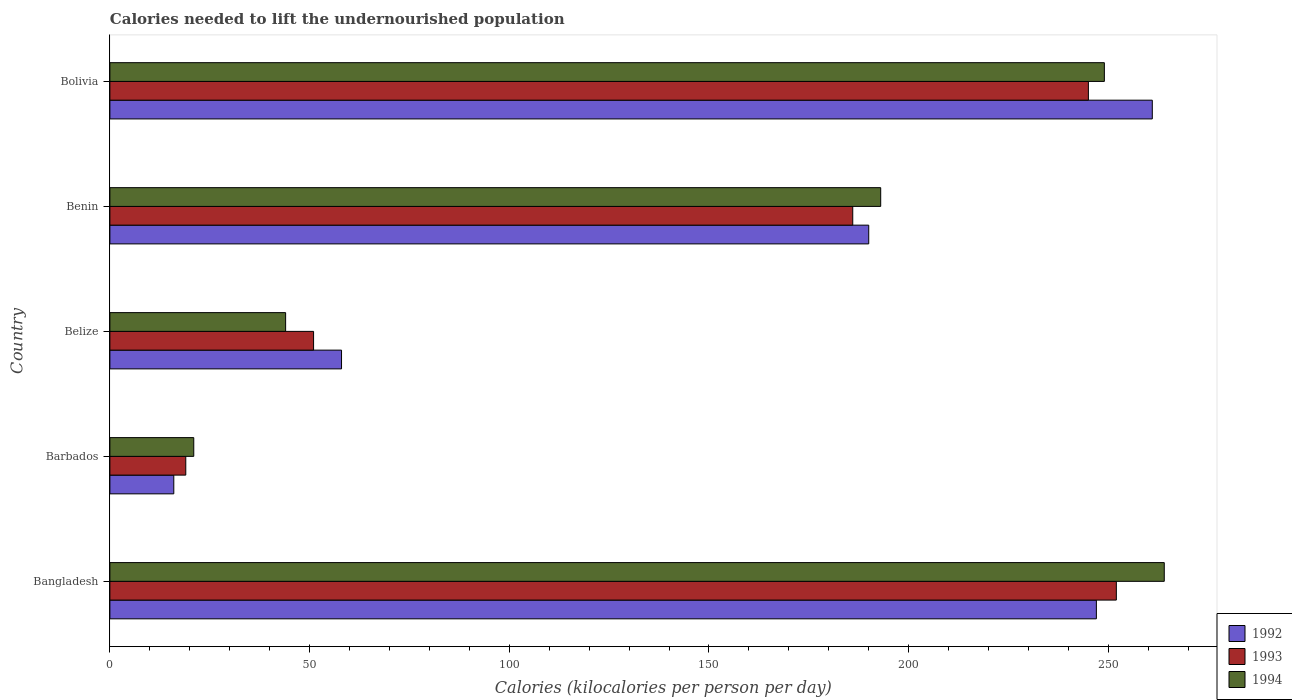Are the number of bars per tick equal to the number of legend labels?
Ensure brevity in your answer.  Yes. Are the number of bars on each tick of the Y-axis equal?
Your answer should be compact. Yes. How many bars are there on the 5th tick from the top?
Your answer should be compact. 3. What is the label of the 2nd group of bars from the top?
Ensure brevity in your answer.  Benin. In how many cases, is the number of bars for a given country not equal to the number of legend labels?
Ensure brevity in your answer.  0. What is the total calories needed to lift the undernourished population in 1992 in Bangladesh?
Your answer should be very brief. 247. Across all countries, what is the maximum total calories needed to lift the undernourished population in 1993?
Your answer should be very brief. 252. In which country was the total calories needed to lift the undernourished population in 1994 maximum?
Offer a terse response. Bangladesh. In which country was the total calories needed to lift the undernourished population in 1992 minimum?
Your answer should be very brief. Barbados. What is the total total calories needed to lift the undernourished population in 1993 in the graph?
Ensure brevity in your answer.  753. What is the difference between the total calories needed to lift the undernourished population in 1993 in Belize and that in Benin?
Provide a succinct answer. -135. What is the difference between the total calories needed to lift the undernourished population in 1994 in Bangladesh and the total calories needed to lift the undernourished population in 1992 in Barbados?
Ensure brevity in your answer.  248. What is the average total calories needed to lift the undernourished population in 1994 per country?
Provide a short and direct response. 154.2. What is the ratio of the total calories needed to lift the undernourished population in 1992 in Benin to that in Bolivia?
Your answer should be very brief. 0.73. Is the difference between the total calories needed to lift the undernourished population in 1993 in Bangladesh and Barbados greater than the difference between the total calories needed to lift the undernourished population in 1992 in Bangladesh and Barbados?
Keep it short and to the point. Yes. What is the difference between the highest and the lowest total calories needed to lift the undernourished population in 1993?
Your response must be concise. 233. In how many countries, is the total calories needed to lift the undernourished population in 1993 greater than the average total calories needed to lift the undernourished population in 1993 taken over all countries?
Your answer should be very brief. 3. Is the sum of the total calories needed to lift the undernourished population in 1992 in Benin and Bolivia greater than the maximum total calories needed to lift the undernourished population in 1994 across all countries?
Give a very brief answer. Yes. What does the 2nd bar from the top in Barbados represents?
Offer a very short reply. 1993. What does the 1st bar from the bottom in Bangladesh represents?
Provide a succinct answer. 1992. Is it the case that in every country, the sum of the total calories needed to lift the undernourished population in 1992 and total calories needed to lift the undernourished population in 1994 is greater than the total calories needed to lift the undernourished population in 1993?
Your answer should be very brief. Yes. How many bars are there?
Provide a short and direct response. 15. Are all the bars in the graph horizontal?
Your response must be concise. Yes. What is the difference between two consecutive major ticks on the X-axis?
Make the answer very short. 50. Does the graph contain grids?
Offer a terse response. No. Where does the legend appear in the graph?
Ensure brevity in your answer.  Bottom right. How many legend labels are there?
Offer a terse response. 3. What is the title of the graph?
Your answer should be compact. Calories needed to lift the undernourished population. Does "1990" appear as one of the legend labels in the graph?
Your response must be concise. No. What is the label or title of the X-axis?
Offer a very short reply. Calories (kilocalories per person per day). What is the Calories (kilocalories per person per day) in 1992 in Bangladesh?
Your answer should be compact. 247. What is the Calories (kilocalories per person per day) of 1993 in Bangladesh?
Your answer should be very brief. 252. What is the Calories (kilocalories per person per day) of 1994 in Bangladesh?
Keep it short and to the point. 264. What is the Calories (kilocalories per person per day) in 1992 in Barbados?
Offer a terse response. 16. What is the Calories (kilocalories per person per day) in 1994 in Barbados?
Provide a succinct answer. 21. What is the Calories (kilocalories per person per day) of 1992 in Belize?
Give a very brief answer. 58. What is the Calories (kilocalories per person per day) of 1994 in Belize?
Offer a very short reply. 44. What is the Calories (kilocalories per person per day) of 1992 in Benin?
Provide a succinct answer. 190. What is the Calories (kilocalories per person per day) of 1993 in Benin?
Provide a short and direct response. 186. What is the Calories (kilocalories per person per day) in 1994 in Benin?
Your answer should be very brief. 193. What is the Calories (kilocalories per person per day) in 1992 in Bolivia?
Your answer should be very brief. 261. What is the Calories (kilocalories per person per day) in 1993 in Bolivia?
Your answer should be very brief. 245. What is the Calories (kilocalories per person per day) of 1994 in Bolivia?
Your response must be concise. 249. Across all countries, what is the maximum Calories (kilocalories per person per day) of 1992?
Give a very brief answer. 261. Across all countries, what is the maximum Calories (kilocalories per person per day) in 1993?
Your response must be concise. 252. Across all countries, what is the maximum Calories (kilocalories per person per day) in 1994?
Your answer should be compact. 264. Across all countries, what is the minimum Calories (kilocalories per person per day) in 1992?
Your answer should be very brief. 16. Across all countries, what is the minimum Calories (kilocalories per person per day) of 1994?
Keep it short and to the point. 21. What is the total Calories (kilocalories per person per day) of 1992 in the graph?
Provide a succinct answer. 772. What is the total Calories (kilocalories per person per day) of 1993 in the graph?
Provide a succinct answer. 753. What is the total Calories (kilocalories per person per day) of 1994 in the graph?
Offer a very short reply. 771. What is the difference between the Calories (kilocalories per person per day) in 1992 in Bangladesh and that in Barbados?
Provide a succinct answer. 231. What is the difference between the Calories (kilocalories per person per day) in 1993 in Bangladesh and that in Barbados?
Give a very brief answer. 233. What is the difference between the Calories (kilocalories per person per day) of 1994 in Bangladesh and that in Barbados?
Make the answer very short. 243. What is the difference between the Calories (kilocalories per person per day) in 1992 in Bangladesh and that in Belize?
Provide a short and direct response. 189. What is the difference between the Calories (kilocalories per person per day) in 1993 in Bangladesh and that in Belize?
Give a very brief answer. 201. What is the difference between the Calories (kilocalories per person per day) of 1994 in Bangladesh and that in Belize?
Your response must be concise. 220. What is the difference between the Calories (kilocalories per person per day) in 1992 in Bangladesh and that in Bolivia?
Your response must be concise. -14. What is the difference between the Calories (kilocalories per person per day) of 1994 in Bangladesh and that in Bolivia?
Your response must be concise. 15. What is the difference between the Calories (kilocalories per person per day) of 1992 in Barbados and that in Belize?
Your answer should be compact. -42. What is the difference between the Calories (kilocalories per person per day) in 1993 in Barbados and that in Belize?
Give a very brief answer. -32. What is the difference between the Calories (kilocalories per person per day) of 1994 in Barbados and that in Belize?
Keep it short and to the point. -23. What is the difference between the Calories (kilocalories per person per day) of 1992 in Barbados and that in Benin?
Offer a terse response. -174. What is the difference between the Calories (kilocalories per person per day) in 1993 in Barbados and that in Benin?
Your response must be concise. -167. What is the difference between the Calories (kilocalories per person per day) in 1994 in Barbados and that in Benin?
Make the answer very short. -172. What is the difference between the Calories (kilocalories per person per day) in 1992 in Barbados and that in Bolivia?
Give a very brief answer. -245. What is the difference between the Calories (kilocalories per person per day) in 1993 in Barbados and that in Bolivia?
Make the answer very short. -226. What is the difference between the Calories (kilocalories per person per day) of 1994 in Barbados and that in Bolivia?
Provide a short and direct response. -228. What is the difference between the Calories (kilocalories per person per day) in 1992 in Belize and that in Benin?
Offer a terse response. -132. What is the difference between the Calories (kilocalories per person per day) of 1993 in Belize and that in Benin?
Your answer should be very brief. -135. What is the difference between the Calories (kilocalories per person per day) in 1994 in Belize and that in Benin?
Give a very brief answer. -149. What is the difference between the Calories (kilocalories per person per day) in 1992 in Belize and that in Bolivia?
Provide a succinct answer. -203. What is the difference between the Calories (kilocalories per person per day) of 1993 in Belize and that in Bolivia?
Provide a short and direct response. -194. What is the difference between the Calories (kilocalories per person per day) in 1994 in Belize and that in Bolivia?
Your answer should be very brief. -205. What is the difference between the Calories (kilocalories per person per day) in 1992 in Benin and that in Bolivia?
Offer a terse response. -71. What is the difference between the Calories (kilocalories per person per day) in 1993 in Benin and that in Bolivia?
Keep it short and to the point. -59. What is the difference between the Calories (kilocalories per person per day) of 1994 in Benin and that in Bolivia?
Your response must be concise. -56. What is the difference between the Calories (kilocalories per person per day) of 1992 in Bangladesh and the Calories (kilocalories per person per day) of 1993 in Barbados?
Keep it short and to the point. 228. What is the difference between the Calories (kilocalories per person per day) in 1992 in Bangladesh and the Calories (kilocalories per person per day) in 1994 in Barbados?
Keep it short and to the point. 226. What is the difference between the Calories (kilocalories per person per day) in 1993 in Bangladesh and the Calories (kilocalories per person per day) in 1994 in Barbados?
Your answer should be compact. 231. What is the difference between the Calories (kilocalories per person per day) in 1992 in Bangladesh and the Calories (kilocalories per person per day) in 1993 in Belize?
Provide a short and direct response. 196. What is the difference between the Calories (kilocalories per person per day) in 1992 in Bangladesh and the Calories (kilocalories per person per day) in 1994 in Belize?
Your answer should be compact. 203. What is the difference between the Calories (kilocalories per person per day) in 1993 in Bangladesh and the Calories (kilocalories per person per day) in 1994 in Belize?
Your answer should be very brief. 208. What is the difference between the Calories (kilocalories per person per day) of 1993 in Bangladesh and the Calories (kilocalories per person per day) of 1994 in Benin?
Your answer should be compact. 59. What is the difference between the Calories (kilocalories per person per day) in 1992 in Bangladesh and the Calories (kilocalories per person per day) in 1994 in Bolivia?
Your answer should be very brief. -2. What is the difference between the Calories (kilocalories per person per day) of 1992 in Barbados and the Calories (kilocalories per person per day) of 1993 in Belize?
Your answer should be compact. -35. What is the difference between the Calories (kilocalories per person per day) in 1992 in Barbados and the Calories (kilocalories per person per day) in 1993 in Benin?
Offer a terse response. -170. What is the difference between the Calories (kilocalories per person per day) in 1992 in Barbados and the Calories (kilocalories per person per day) in 1994 in Benin?
Make the answer very short. -177. What is the difference between the Calories (kilocalories per person per day) in 1993 in Barbados and the Calories (kilocalories per person per day) in 1994 in Benin?
Provide a succinct answer. -174. What is the difference between the Calories (kilocalories per person per day) of 1992 in Barbados and the Calories (kilocalories per person per day) of 1993 in Bolivia?
Offer a very short reply. -229. What is the difference between the Calories (kilocalories per person per day) in 1992 in Barbados and the Calories (kilocalories per person per day) in 1994 in Bolivia?
Make the answer very short. -233. What is the difference between the Calories (kilocalories per person per day) of 1993 in Barbados and the Calories (kilocalories per person per day) of 1994 in Bolivia?
Make the answer very short. -230. What is the difference between the Calories (kilocalories per person per day) in 1992 in Belize and the Calories (kilocalories per person per day) in 1993 in Benin?
Offer a terse response. -128. What is the difference between the Calories (kilocalories per person per day) in 1992 in Belize and the Calories (kilocalories per person per day) in 1994 in Benin?
Give a very brief answer. -135. What is the difference between the Calories (kilocalories per person per day) of 1993 in Belize and the Calories (kilocalories per person per day) of 1994 in Benin?
Your response must be concise. -142. What is the difference between the Calories (kilocalories per person per day) of 1992 in Belize and the Calories (kilocalories per person per day) of 1993 in Bolivia?
Provide a succinct answer. -187. What is the difference between the Calories (kilocalories per person per day) of 1992 in Belize and the Calories (kilocalories per person per day) of 1994 in Bolivia?
Make the answer very short. -191. What is the difference between the Calories (kilocalories per person per day) in 1993 in Belize and the Calories (kilocalories per person per day) in 1994 in Bolivia?
Provide a short and direct response. -198. What is the difference between the Calories (kilocalories per person per day) of 1992 in Benin and the Calories (kilocalories per person per day) of 1993 in Bolivia?
Ensure brevity in your answer.  -55. What is the difference between the Calories (kilocalories per person per day) of 1992 in Benin and the Calories (kilocalories per person per day) of 1994 in Bolivia?
Your answer should be compact. -59. What is the difference between the Calories (kilocalories per person per day) in 1993 in Benin and the Calories (kilocalories per person per day) in 1994 in Bolivia?
Make the answer very short. -63. What is the average Calories (kilocalories per person per day) in 1992 per country?
Ensure brevity in your answer.  154.4. What is the average Calories (kilocalories per person per day) in 1993 per country?
Your answer should be compact. 150.6. What is the average Calories (kilocalories per person per day) in 1994 per country?
Keep it short and to the point. 154.2. What is the difference between the Calories (kilocalories per person per day) in 1992 and Calories (kilocalories per person per day) in 1993 in Bangladesh?
Offer a terse response. -5. What is the difference between the Calories (kilocalories per person per day) of 1992 and Calories (kilocalories per person per day) of 1994 in Barbados?
Ensure brevity in your answer.  -5. What is the difference between the Calories (kilocalories per person per day) in 1993 and Calories (kilocalories per person per day) in 1994 in Barbados?
Ensure brevity in your answer.  -2. What is the difference between the Calories (kilocalories per person per day) of 1992 and Calories (kilocalories per person per day) of 1994 in Belize?
Provide a short and direct response. 14. What is the difference between the Calories (kilocalories per person per day) of 1993 and Calories (kilocalories per person per day) of 1994 in Belize?
Ensure brevity in your answer.  7. What is the difference between the Calories (kilocalories per person per day) of 1993 and Calories (kilocalories per person per day) of 1994 in Benin?
Keep it short and to the point. -7. What is the difference between the Calories (kilocalories per person per day) in 1992 and Calories (kilocalories per person per day) in 1994 in Bolivia?
Provide a succinct answer. 12. What is the ratio of the Calories (kilocalories per person per day) in 1992 in Bangladesh to that in Barbados?
Provide a short and direct response. 15.44. What is the ratio of the Calories (kilocalories per person per day) of 1993 in Bangladesh to that in Barbados?
Provide a succinct answer. 13.26. What is the ratio of the Calories (kilocalories per person per day) in 1994 in Bangladesh to that in Barbados?
Make the answer very short. 12.57. What is the ratio of the Calories (kilocalories per person per day) in 1992 in Bangladesh to that in Belize?
Ensure brevity in your answer.  4.26. What is the ratio of the Calories (kilocalories per person per day) in 1993 in Bangladesh to that in Belize?
Provide a short and direct response. 4.94. What is the ratio of the Calories (kilocalories per person per day) in 1993 in Bangladesh to that in Benin?
Offer a terse response. 1.35. What is the ratio of the Calories (kilocalories per person per day) of 1994 in Bangladesh to that in Benin?
Give a very brief answer. 1.37. What is the ratio of the Calories (kilocalories per person per day) in 1992 in Bangladesh to that in Bolivia?
Ensure brevity in your answer.  0.95. What is the ratio of the Calories (kilocalories per person per day) in 1993 in Bangladesh to that in Bolivia?
Offer a terse response. 1.03. What is the ratio of the Calories (kilocalories per person per day) of 1994 in Bangladesh to that in Bolivia?
Provide a short and direct response. 1.06. What is the ratio of the Calories (kilocalories per person per day) in 1992 in Barbados to that in Belize?
Your answer should be compact. 0.28. What is the ratio of the Calories (kilocalories per person per day) of 1993 in Barbados to that in Belize?
Your answer should be very brief. 0.37. What is the ratio of the Calories (kilocalories per person per day) of 1994 in Barbados to that in Belize?
Your answer should be compact. 0.48. What is the ratio of the Calories (kilocalories per person per day) in 1992 in Barbados to that in Benin?
Offer a very short reply. 0.08. What is the ratio of the Calories (kilocalories per person per day) of 1993 in Barbados to that in Benin?
Your answer should be very brief. 0.1. What is the ratio of the Calories (kilocalories per person per day) of 1994 in Barbados to that in Benin?
Make the answer very short. 0.11. What is the ratio of the Calories (kilocalories per person per day) in 1992 in Barbados to that in Bolivia?
Make the answer very short. 0.06. What is the ratio of the Calories (kilocalories per person per day) in 1993 in Barbados to that in Bolivia?
Keep it short and to the point. 0.08. What is the ratio of the Calories (kilocalories per person per day) in 1994 in Barbados to that in Bolivia?
Make the answer very short. 0.08. What is the ratio of the Calories (kilocalories per person per day) of 1992 in Belize to that in Benin?
Your answer should be very brief. 0.31. What is the ratio of the Calories (kilocalories per person per day) in 1993 in Belize to that in Benin?
Ensure brevity in your answer.  0.27. What is the ratio of the Calories (kilocalories per person per day) of 1994 in Belize to that in Benin?
Your answer should be very brief. 0.23. What is the ratio of the Calories (kilocalories per person per day) in 1992 in Belize to that in Bolivia?
Provide a short and direct response. 0.22. What is the ratio of the Calories (kilocalories per person per day) of 1993 in Belize to that in Bolivia?
Ensure brevity in your answer.  0.21. What is the ratio of the Calories (kilocalories per person per day) in 1994 in Belize to that in Bolivia?
Make the answer very short. 0.18. What is the ratio of the Calories (kilocalories per person per day) in 1992 in Benin to that in Bolivia?
Make the answer very short. 0.73. What is the ratio of the Calories (kilocalories per person per day) of 1993 in Benin to that in Bolivia?
Your answer should be compact. 0.76. What is the ratio of the Calories (kilocalories per person per day) of 1994 in Benin to that in Bolivia?
Provide a succinct answer. 0.78. What is the difference between the highest and the second highest Calories (kilocalories per person per day) in 1992?
Give a very brief answer. 14. What is the difference between the highest and the second highest Calories (kilocalories per person per day) in 1993?
Your answer should be compact. 7. What is the difference between the highest and the lowest Calories (kilocalories per person per day) of 1992?
Ensure brevity in your answer.  245. What is the difference between the highest and the lowest Calories (kilocalories per person per day) of 1993?
Your answer should be compact. 233. What is the difference between the highest and the lowest Calories (kilocalories per person per day) in 1994?
Your answer should be very brief. 243. 